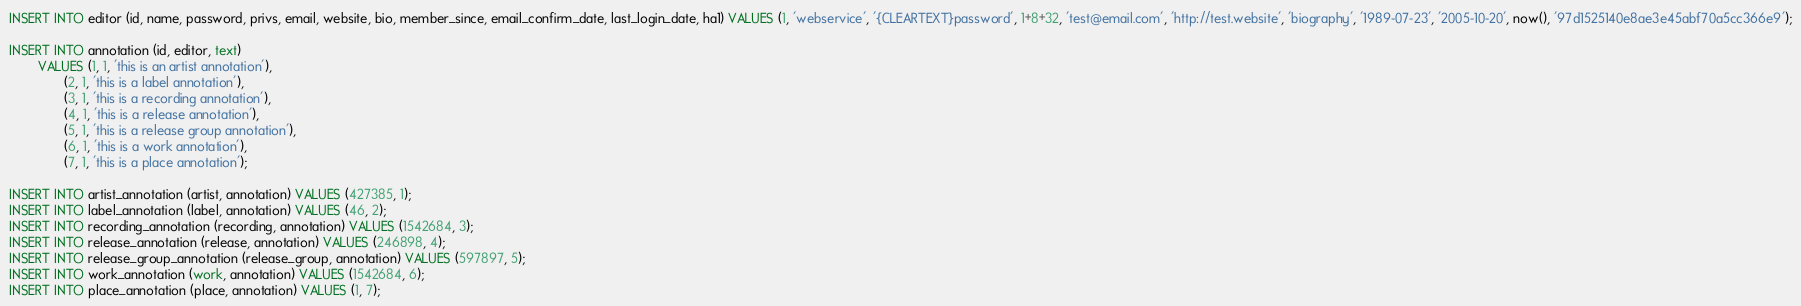Convert code to text. <code><loc_0><loc_0><loc_500><loc_500><_SQL_>INSERT INTO editor (id, name, password, privs, email, website, bio, member_since, email_confirm_date, last_login_date, ha1) VALUES (1, 'webservice', '{CLEARTEXT}password', 1+8+32, 'test@email.com', 'http://test.website', 'biography', '1989-07-23', '2005-10-20', now(), '97d1525140e8ae3e45abf70a5cc366e9');

INSERT INTO annotation (id, editor, text)
        VALUES (1, 1, 'this is an artist annotation'),
               (2, 1, 'this is a label annotation'),
               (3, 1, 'this is a recording annotation'),
               (4, 1, 'this is a release annotation'),
               (5, 1, 'this is a release group annotation'),
               (6, 1, 'this is a work annotation'),
               (7, 1, 'this is a place annotation');

INSERT INTO artist_annotation (artist, annotation) VALUES (427385, 1);
INSERT INTO label_annotation (label, annotation) VALUES (46, 2);
INSERT INTO recording_annotation (recording, annotation) VALUES (1542684, 3);
INSERT INTO release_annotation (release, annotation) VALUES (246898, 4);
INSERT INTO release_group_annotation (release_group, annotation) VALUES (597897, 5);
INSERT INTO work_annotation (work, annotation) VALUES (1542684, 6);
INSERT INTO place_annotation (place, annotation) VALUES (1, 7);
</code> 